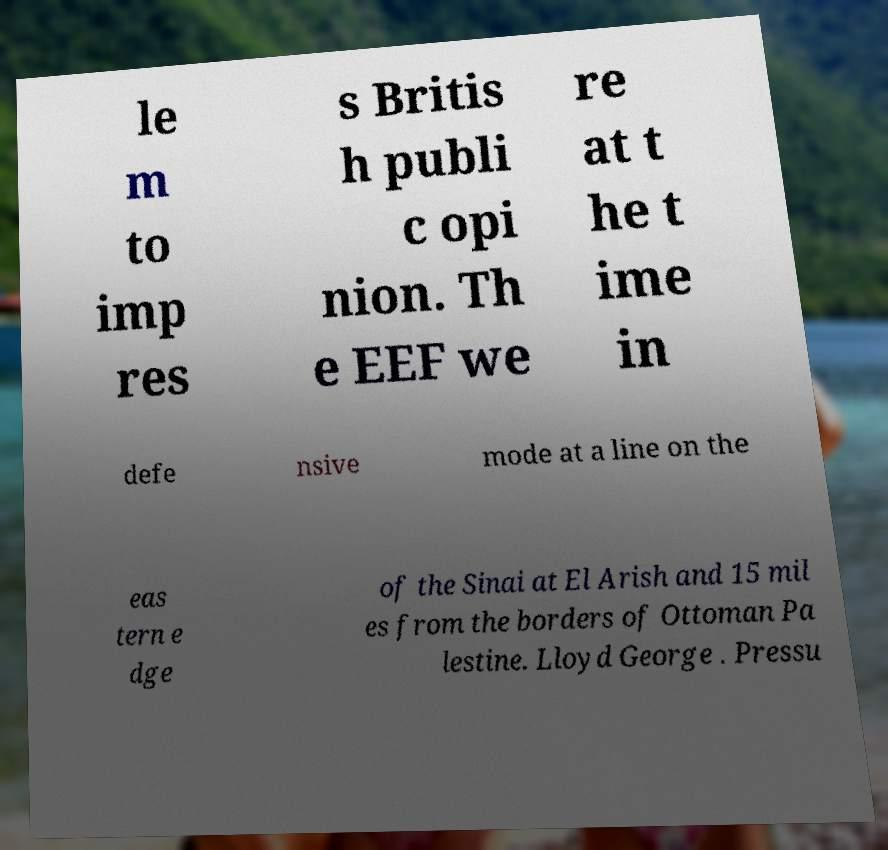Could you assist in decoding the text presented in this image and type it out clearly? le m to imp res s Britis h publi c opi nion. Th e EEF we re at t he t ime in defe nsive mode at a line on the eas tern e dge of the Sinai at El Arish and 15 mil es from the borders of Ottoman Pa lestine. Lloyd George . Pressu 